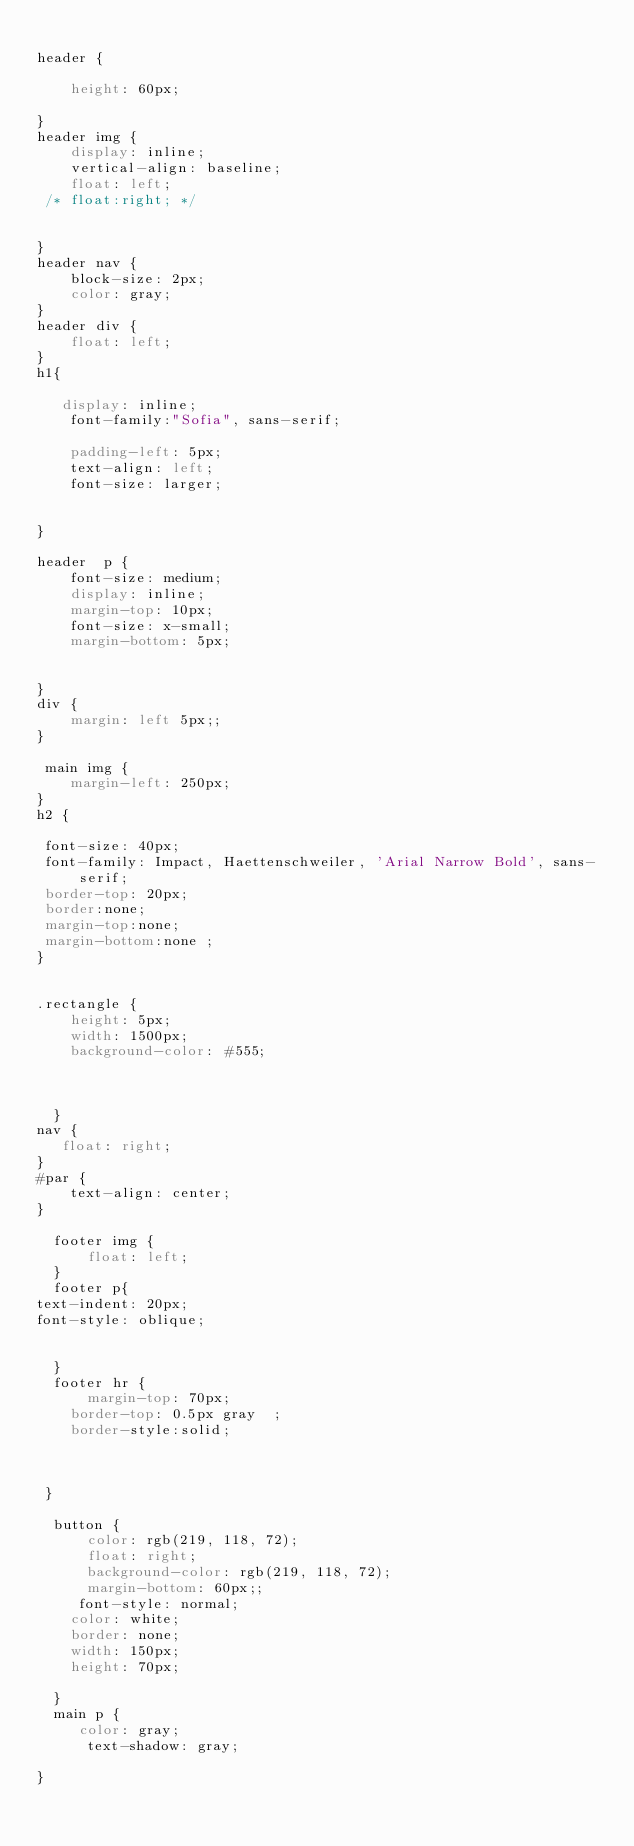<code> <loc_0><loc_0><loc_500><loc_500><_CSS_>
header {
   
    height: 60px;
    
}
header img { 
    display: inline;
    vertical-align: baseline;
    float: left;
 /* float:right; */
   

}
header nav {
    block-size: 2px;
    color: gray;
}
header div {
    float: left;
}
h1{

   display: inline;
    font-family:"Sofia", sans-serif;
   
    padding-left: 5px;
    text-align: left;
    font-size: larger;
    
   
}

header  p {
    font-size: medium;
    display: inline;
    margin-top: 10px;
    font-size: x-small;
    margin-bottom: 5px;
    

}
div {
    margin: left 5px;;
}

 main img {
    margin-left: 250px;
}
h2 { 

 font-size: 40px;
 font-family: Impact, Haettenschweiler, 'Arial Narrow Bold', sans-serif;
 border-top: 20px;
 border:none;
 margin-top:none;
 margin-bottom:none ;
}
 

.rectangle {
    height: 5px;
    width: 1500px;
    background-color: #555;


    
  }
nav {
   float: right;
}
#par {
    text-align: center;
}

  footer img {
      float: left;
  }
  footer p{
text-indent: 20px;
font-style: oblique;


  }
  footer hr {
      margin-top: 70px;
    border-top: 0.5px gray  ;
    border-style:solid;
    
   

 }

  button {
      color: rgb(219, 118, 72);
      float: right;
      background-color: rgb(219, 118, 72);
      margin-bottom: 60px;;
     font-style: normal;
    color: white;
    border: none;
    width: 150px;
    height: 70px;

  }
  main p { 
     color: gray;
      text-shadow: gray;
      
}
  </code> 